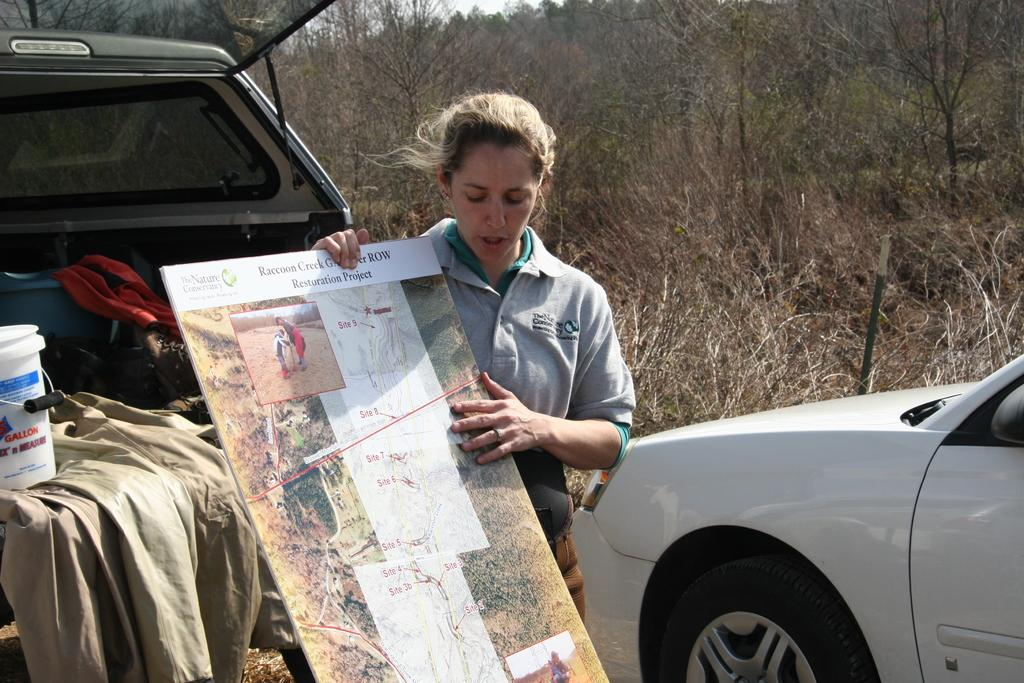What is the person in the image doing? The person is standing in the image and holding a board in her hand. What can be seen behind the person? There are two vehicles behind the person. What is visible in the background of the image? Trees and the sky are visible in the background of the image. How many eyes can be seen on the person's face in the image? There is no face visible in the image, so it is not possible to determine the number of eyes. 